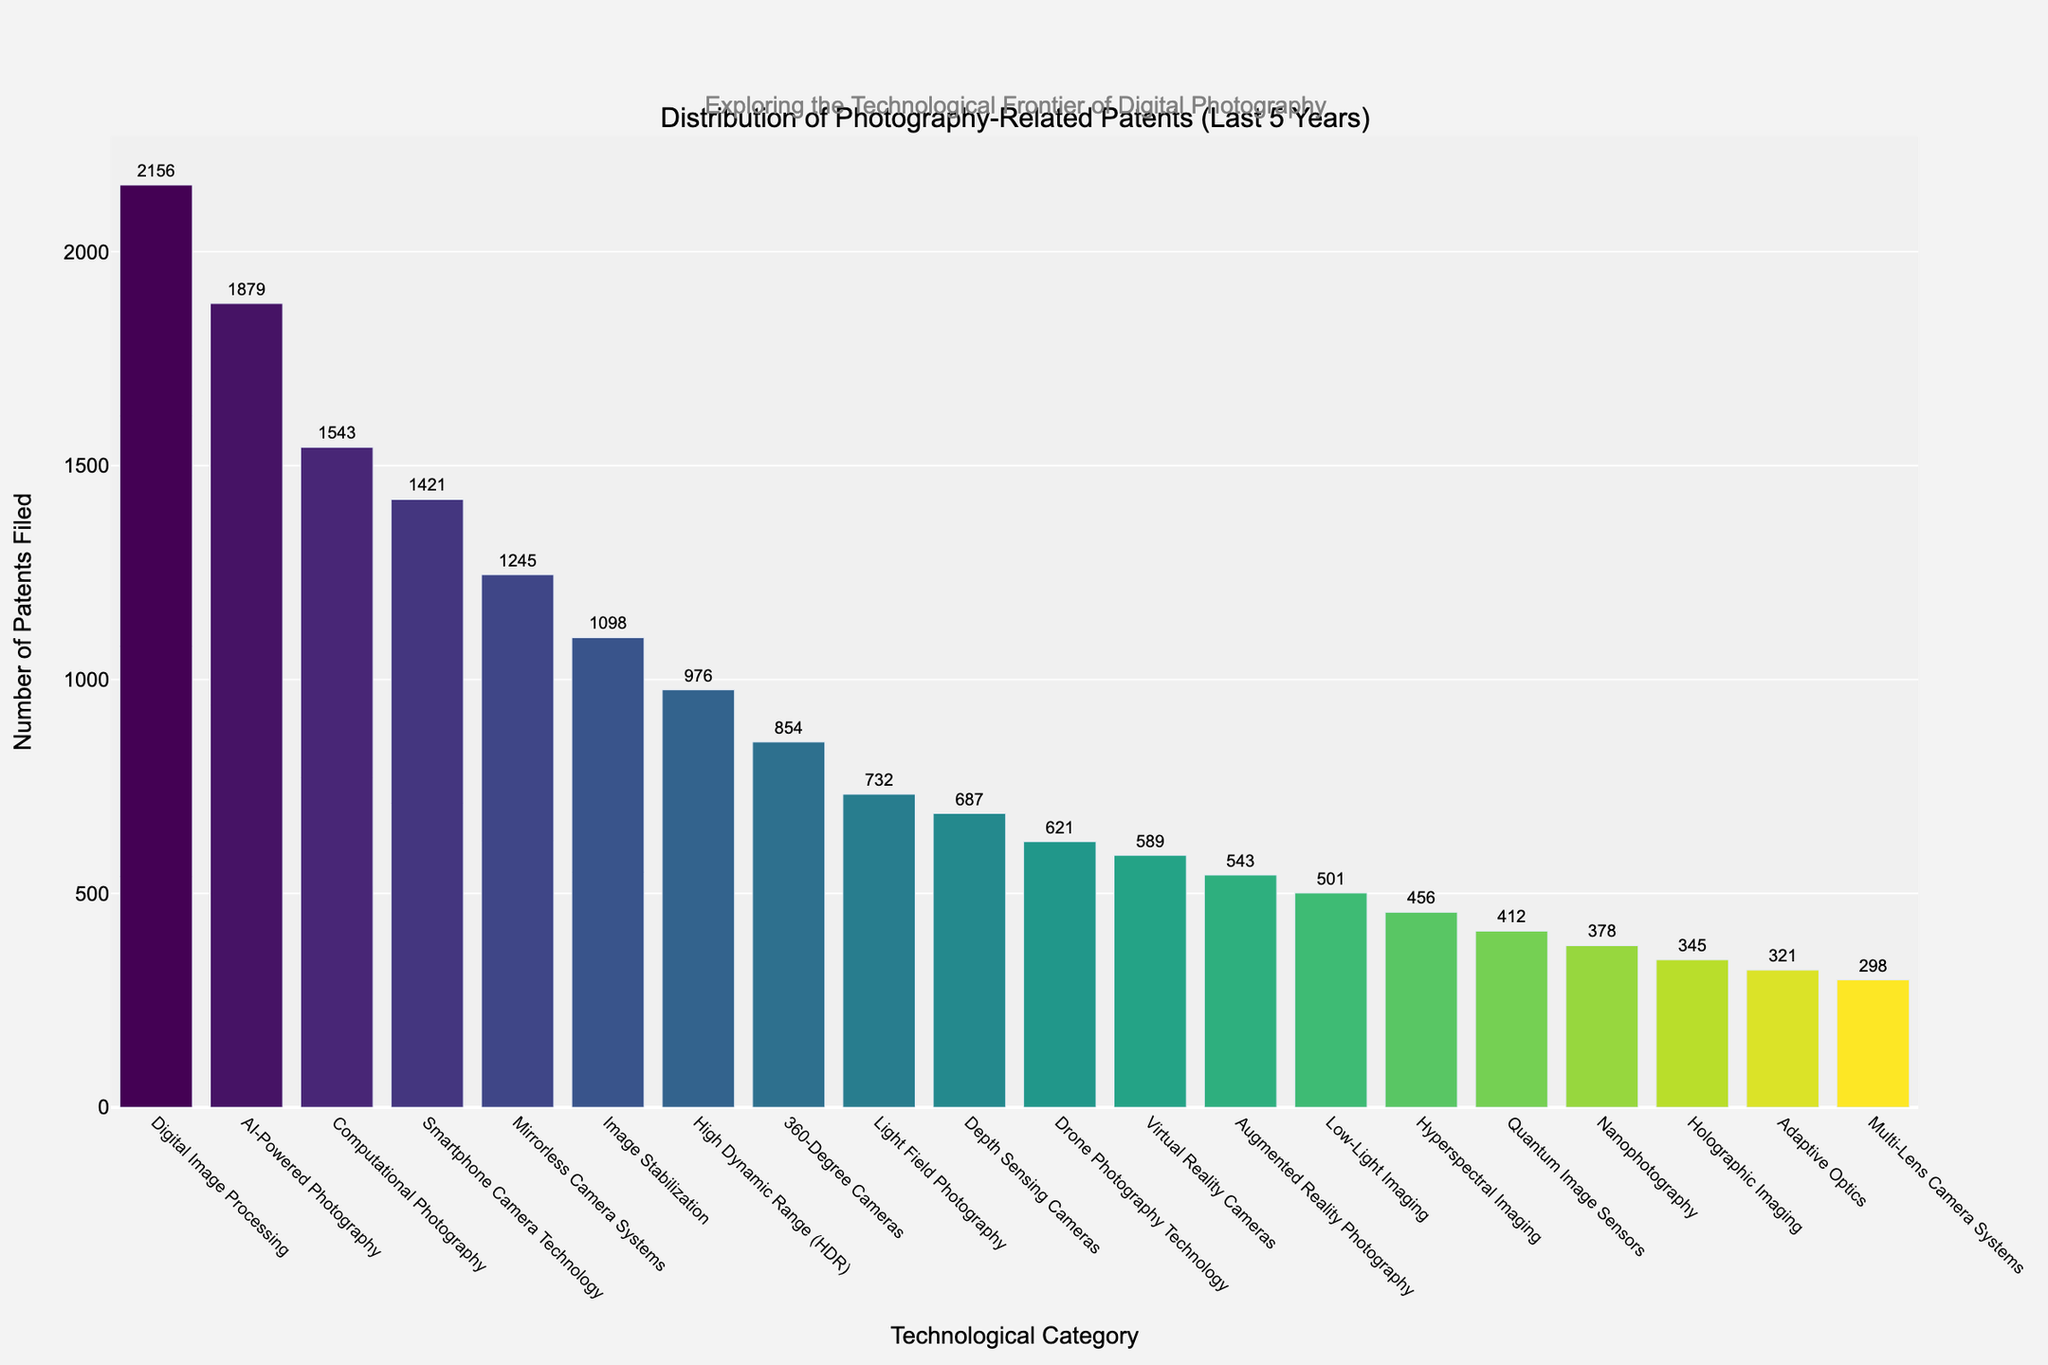What are the top three categories with the most patents filed? The figure shows the bar chart sorted in descending order by the number of patents filed. The first three bars represent the top three categories.
Answer: Digital Image Processing, AI-Powered Photography, Computational Photography How many more patents were filed in Digital Image Processing compared to Low-Light Imaging? Identify the bars for Digital Image Processing and Low-Light Imaging and subtract the number of patents for Low-Light Imaging from that of Digital Image Processing.
Answer: 1655 Which category has fewer patents filed: Holographic Imaging or Nanophotography? Compare the height of the bars for Holographic Imaging and Nanophotography.
Answer: Holographic Imaging What is the combined total number of patents filed for Image Stabilization and Depth Sensing Cameras? Sum the number of patents for Image Stabilization and Depth Sensing Cameras.
Answer: 1785 By how much does the number of patents filed in Smartphone Camera Technology exceed that of Low-Light Imaging? Subtract the number of patents for Low-Light Imaging from that of Smartphone Camera Technology.
Answer: 920 What proportion of the total patents filed is represented by Quantum Image Sensors and Adaptive Optics combined? Sum the numbers of patents for Quantum Image Sensors and Adaptive Optics, then divide by the total number of patents across all categories, and convert it to a percentage.
Answer: (412 + 321) / 18260 ≈ 4.0% How does the number of patents in Virtual Reality Cameras compare to those in Augmented Reality Photography? Compare the heights of the bars for Virtual Reality Cameras and Augmented Reality Photography.
Answer: Higher What is the difference in the number of patents filed between 360-Degree Cameras and Light Field Photography? Subtract the number of patents for Light Field Photography from that of 360-Degree Cameras.
Answer: 122 What is the average number of patents filed across all categories? Sum the number of patents for all categories and divide by the total number of categories (20).
Answer: 913 Rank the categories that have fewer than 600 patents filed. Identify categories with bars representing fewer than 600 patents, then arrange them in ascending order based on the number of patents filed.
Answer: Quantum Image Sensors, Nanophotography, Holographic Imaging, Adaptive Optics, Multi-Lens Camera Systems 